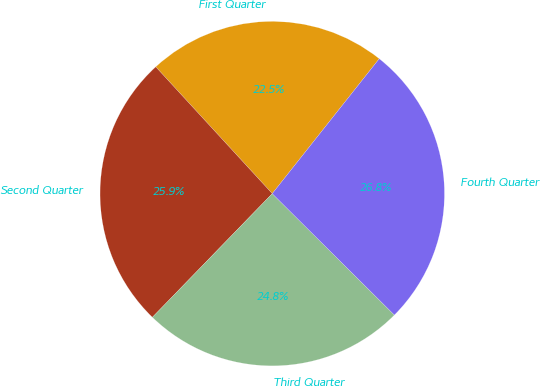<chart> <loc_0><loc_0><loc_500><loc_500><pie_chart><fcel>First Quarter<fcel>Second Quarter<fcel>Third Quarter<fcel>Fourth Quarter<nl><fcel>22.5%<fcel>25.92%<fcel>24.8%<fcel>26.78%<nl></chart> 